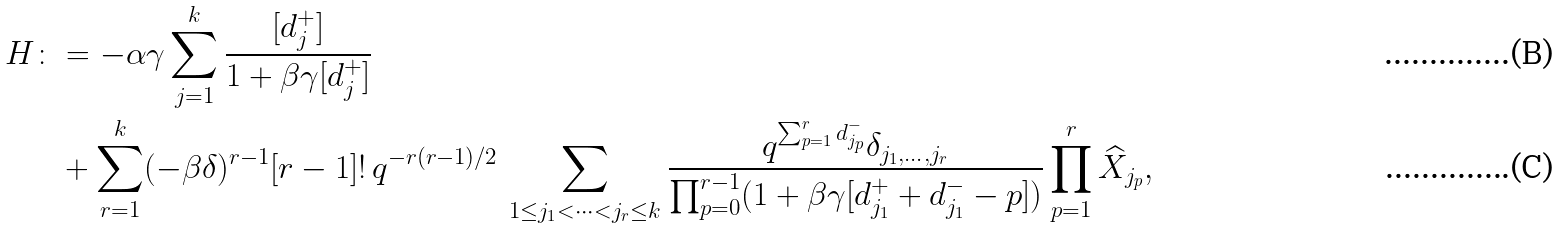<formula> <loc_0><loc_0><loc_500><loc_500>H \colon & = - \alpha \gamma \sum _ { j = 1 } ^ { k } \frac { [ d _ { j } ^ { + } ] } { 1 + \beta \gamma [ d _ { j } ^ { + } ] } \\ & + \sum _ { r = 1 } ^ { k } ( - \beta \delta ) ^ { r - 1 } [ r - 1 ] ! \, q ^ { - r ( r - 1 ) / 2 } \, \sum _ { 1 \leq j _ { 1 } < \cdots < j _ { r } \leq k } \frac { q ^ { \sum _ { p = 1 } ^ { r } d _ { j _ { p } } ^ { - } } \delta _ { j _ { 1 } , \dots , j _ { r } } } { \prod _ { p = 0 } ^ { r - 1 } ( 1 + \beta \gamma [ d _ { j _ { 1 } } ^ { + } + d _ { j _ { 1 } } ^ { - } - p ] ) } \prod _ { p = 1 } ^ { r } \widehat { X } _ { j _ { p } } ,</formula> 